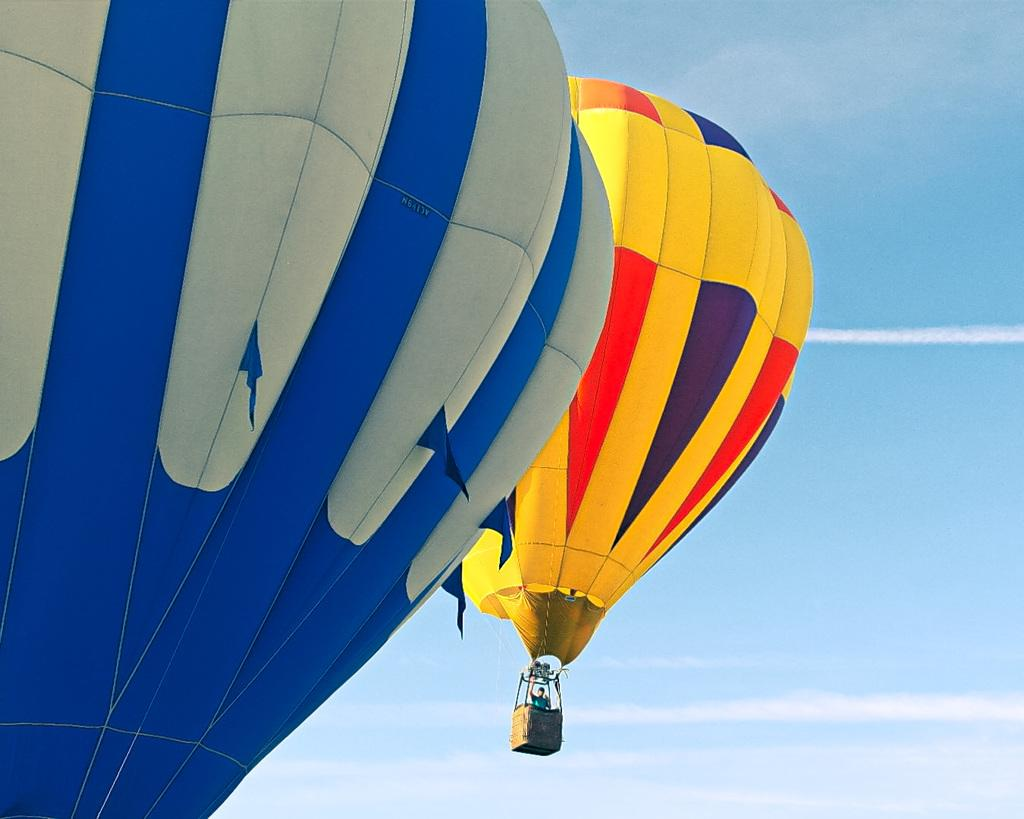How many gas balloons are in the image? There are two gas balloons in the image. What colors are the gas balloons? One gas balloon is blue, and the other is yellow. Is there anyone in either of the gas balloons? Yes, there is a person in the yellow gas balloon. Where are the gas balloons located? The gas balloons are in the air. How many books can be seen in the image? There are no books present in the image; it features two gas balloons, one of which has a person inside. What type of ear is visible on the person in the yellow gas balloon? There is no ear visible on the person in the yellow gas balloon, as the image does not show any details of the person's face or body. 